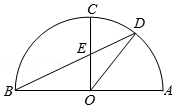In the given figure, if we extend line OD to intersect the semicircle at point F, what can we say about the angles in triangle OFC? With OF intersecting the semicircle at point F, creating triangle OFC, angle OFC would measure 90 degrees since it is inscribed in a semicircle and the endpoints lie on the diameter. Given that triangle OFC would be a right-angled triangle, we could use trigonometric ratios to calculate unknown sides if the lengths of any two sides were known. 